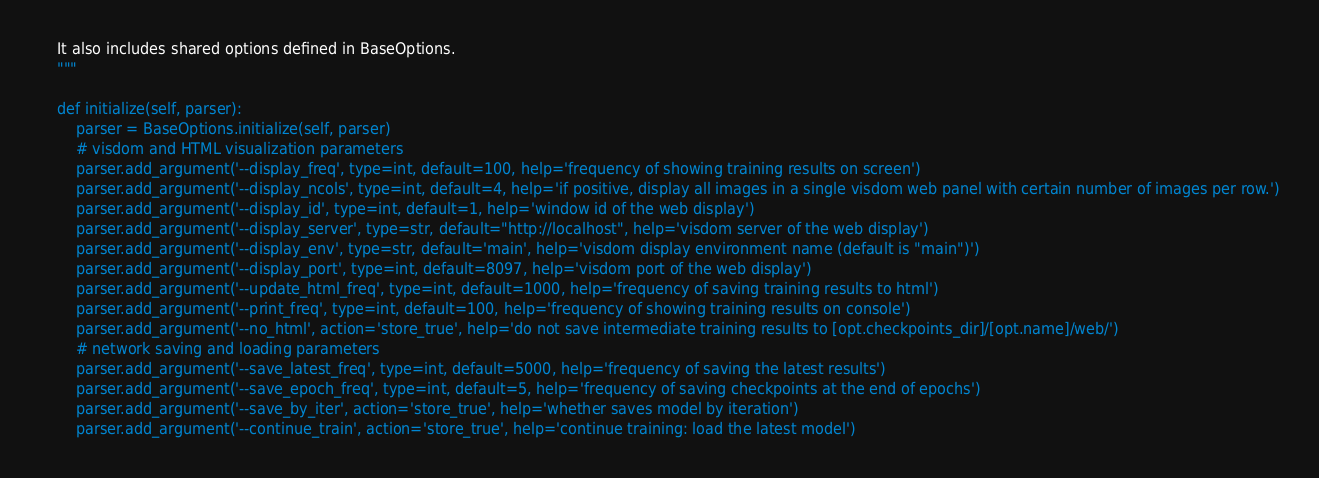<code> <loc_0><loc_0><loc_500><loc_500><_Python_>
    It also includes shared options defined in BaseOptions.
    """

    def initialize(self, parser):
        parser = BaseOptions.initialize(self, parser)
        # visdom and HTML visualization parameters
        parser.add_argument('--display_freq', type=int, default=100, help='frequency of showing training results on screen')
        parser.add_argument('--display_ncols', type=int, default=4, help='if positive, display all images in a single visdom web panel with certain number of images per row.')
        parser.add_argument('--display_id', type=int, default=1, help='window id of the web display')
        parser.add_argument('--display_server', type=str, default="http://localhost", help='visdom server of the web display')
        parser.add_argument('--display_env', type=str, default='main', help='visdom display environment name (default is "main")')
        parser.add_argument('--display_port', type=int, default=8097, help='visdom port of the web display')
        parser.add_argument('--update_html_freq', type=int, default=1000, help='frequency of saving training results to html')
        parser.add_argument('--print_freq', type=int, default=100, help='frequency of showing training results on console')
        parser.add_argument('--no_html', action='store_true', help='do not save intermediate training results to [opt.checkpoints_dir]/[opt.name]/web/')
        # network saving and loading parameters
        parser.add_argument('--save_latest_freq', type=int, default=5000, help='frequency of saving the latest results')
        parser.add_argument('--save_epoch_freq', type=int, default=5, help='frequency of saving checkpoints at the end of epochs')
        parser.add_argument('--save_by_iter', action='store_true', help='whether saves model by iteration')
        parser.add_argument('--continue_train', action='store_true', help='continue training: load the latest model')</code> 